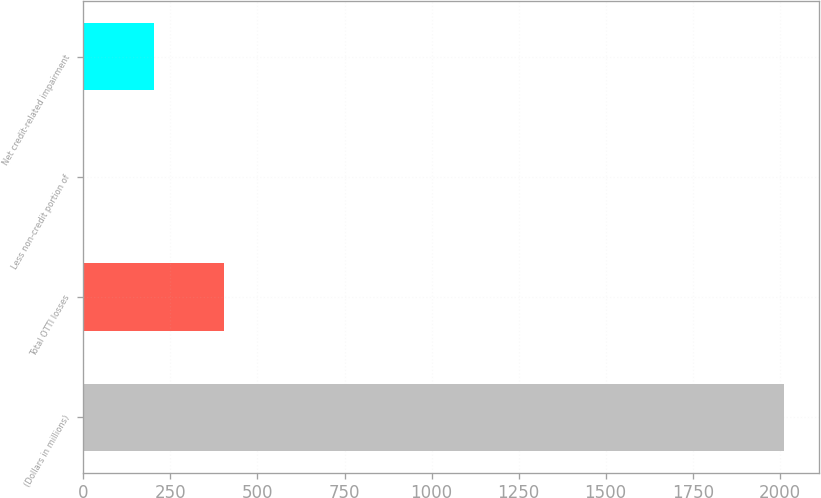Convert chart. <chart><loc_0><loc_0><loc_500><loc_500><bar_chart><fcel>(Dollars in millions)<fcel>Total OTTI losses<fcel>Less non-credit portion of<fcel>Net credit-related impairment<nl><fcel>2013<fcel>403.4<fcel>1<fcel>202.2<nl></chart> 